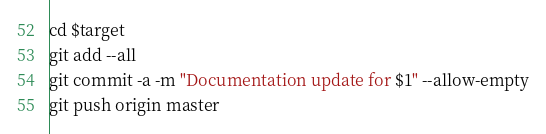<code> <loc_0><loc_0><loc_500><loc_500><_Bash_>cd $target
git add --all
git commit -a -m "Documentation update for $1" --allow-empty
git push origin master
</code> 